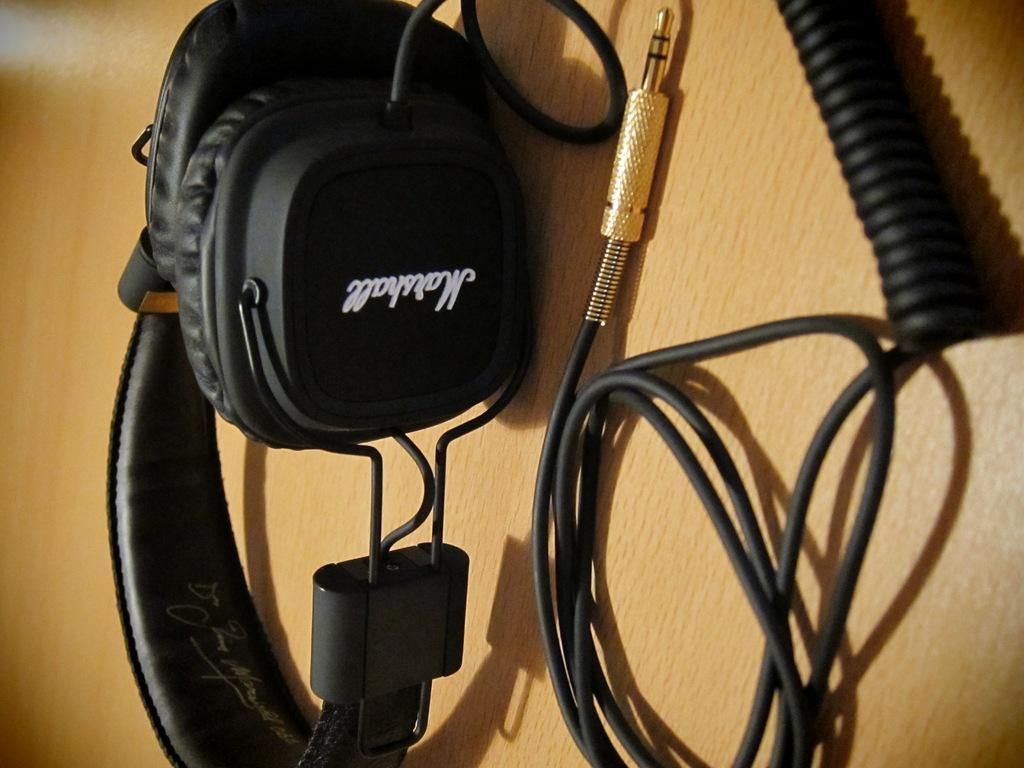Please provide a concise description of this image. In the foreground area of the image there is headset and plug in pin wire on a wooden surface. 